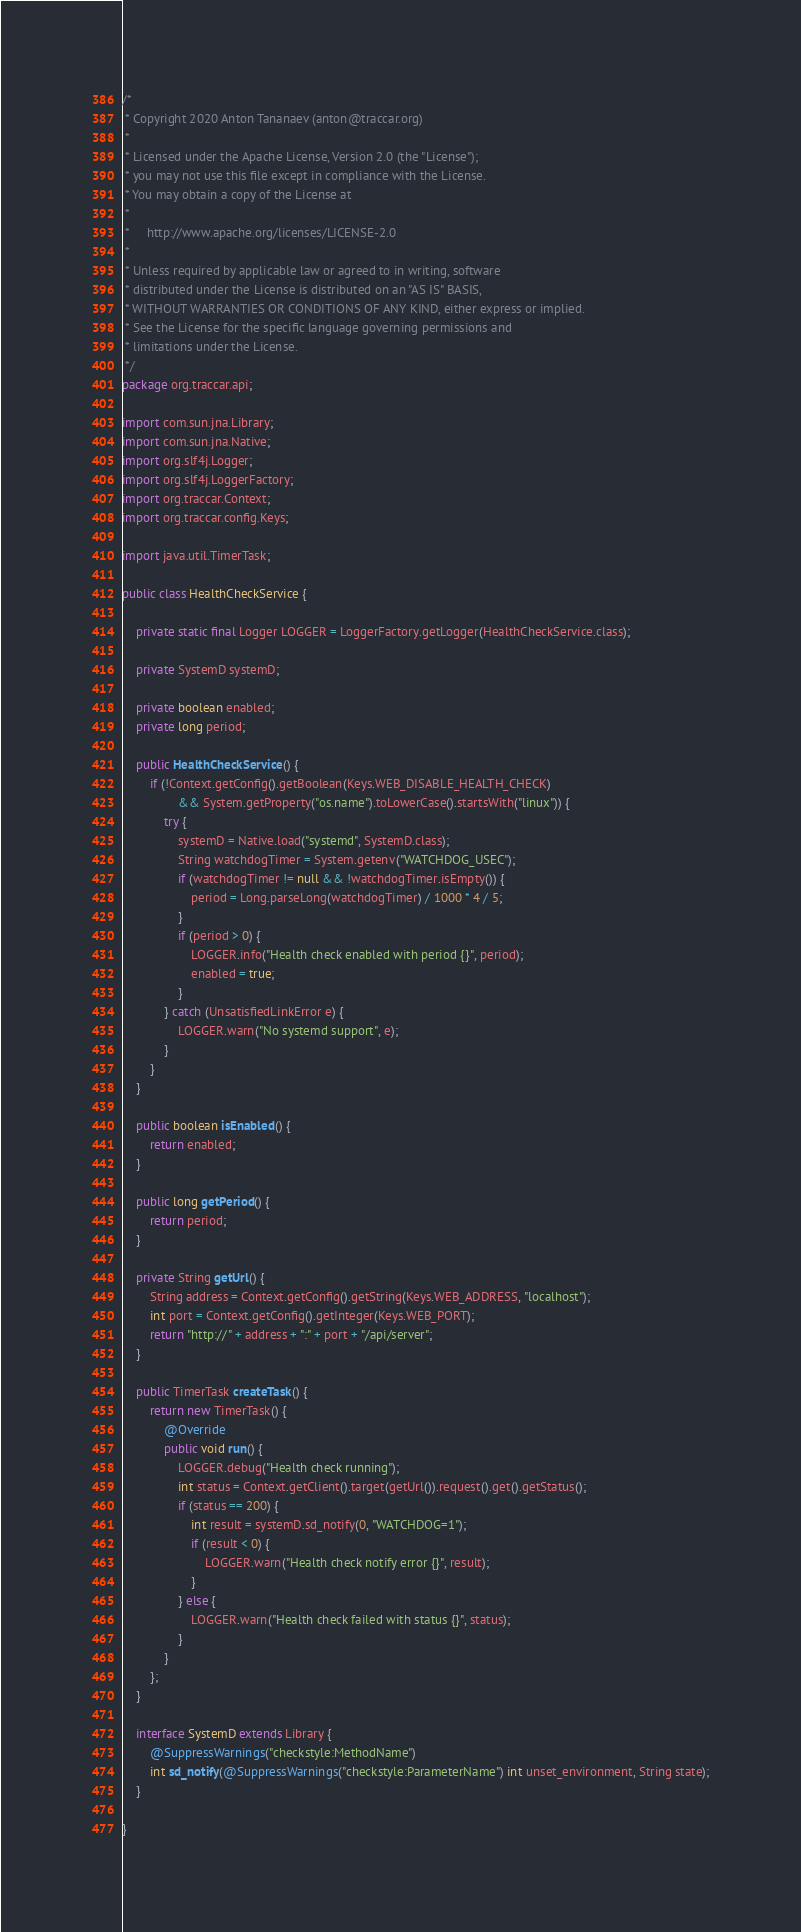<code> <loc_0><loc_0><loc_500><loc_500><_Java_>/*
 * Copyright 2020 Anton Tananaev (anton@traccar.org)
 *
 * Licensed under the Apache License, Version 2.0 (the "License");
 * you may not use this file except in compliance with the License.
 * You may obtain a copy of the License at
 *
 *     http://www.apache.org/licenses/LICENSE-2.0
 *
 * Unless required by applicable law or agreed to in writing, software
 * distributed under the License is distributed on an "AS IS" BASIS,
 * WITHOUT WARRANTIES OR CONDITIONS OF ANY KIND, either express or implied.
 * See the License for the specific language governing permissions and
 * limitations under the License.
 */
package org.traccar.api;

import com.sun.jna.Library;
import com.sun.jna.Native;
import org.slf4j.Logger;
import org.slf4j.LoggerFactory;
import org.traccar.Context;
import org.traccar.config.Keys;

import java.util.TimerTask;

public class HealthCheckService {

	private static final Logger LOGGER = LoggerFactory.getLogger(HealthCheckService.class);

	private SystemD systemD;

	private boolean enabled;
	private long period;

	public HealthCheckService() {
		if (!Context.getConfig().getBoolean(Keys.WEB_DISABLE_HEALTH_CHECK)
				&& System.getProperty("os.name").toLowerCase().startsWith("linux")) {
			try {
				systemD = Native.load("systemd", SystemD.class);
				String watchdogTimer = System.getenv("WATCHDOG_USEC");
				if (watchdogTimer != null && !watchdogTimer.isEmpty()) {
					period = Long.parseLong(watchdogTimer) / 1000 * 4 / 5;
				}
				if (period > 0) {
					LOGGER.info("Health check enabled with period {}", period);
					enabled = true;
				}
			} catch (UnsatisfiedLinkError e) {
				LOGGER.warn("No systemd support", e);
			}
		}
	}

	public boolean isEnabled() {
		return enabled;
	}

	public long getPeriod() {
		return period;
	}

	private String getUrl() {
		String address = Context.getConfig().getString(Keys.WEB_ADDRESS, "localhost");
		int port = Context.getConfig().getInteger(Keys.WEB_PORT);
		return "http://" + address + ":" + port + "/api/server";
	}

	public TimerTask createTask() {
		return new TimerTask() {
			@Override
			public void run() {
				LOGGER.debug("Health check running");
				int status = Context.getClient().target(getUrl()).request().get().getStatus();
				if (status == 200) {
					int result = systemD.sd_notify(0, "WATCHDOG=1");
					if (result < 0) {
						LOGGER.warn("Health check notify error {}", result);
					}
				} else {
					LOGGER.warn("Health check failed with status {}", status);
				}
			}
		};
	}

	interface SystemD extends Library {
		@SuppressWarnings("checkstyle:MethodName")
		int sd_notify(@SuppressWarnings("checkstyle:ParameterName") int unset_environment, String state);
	}

}
</code> 